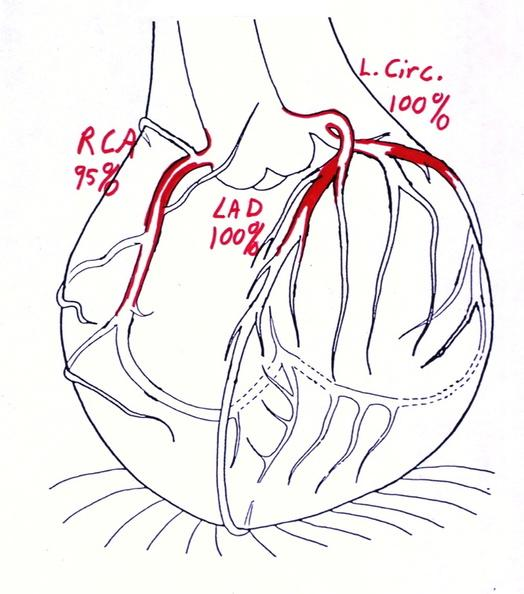s cardiovascular present?
Answer the question using a single word or phrase. Yes 